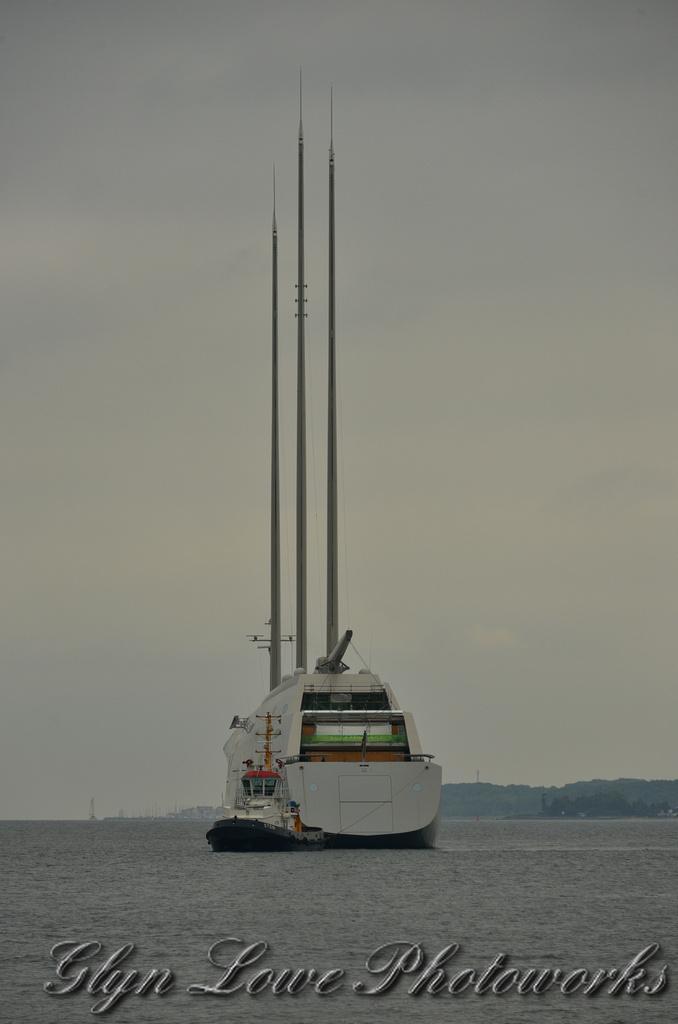How would you summarize this image in a sentence or two? In the center of the image we can see a ship on the water. In the background there are hills and sky. At the bottom there is text. 